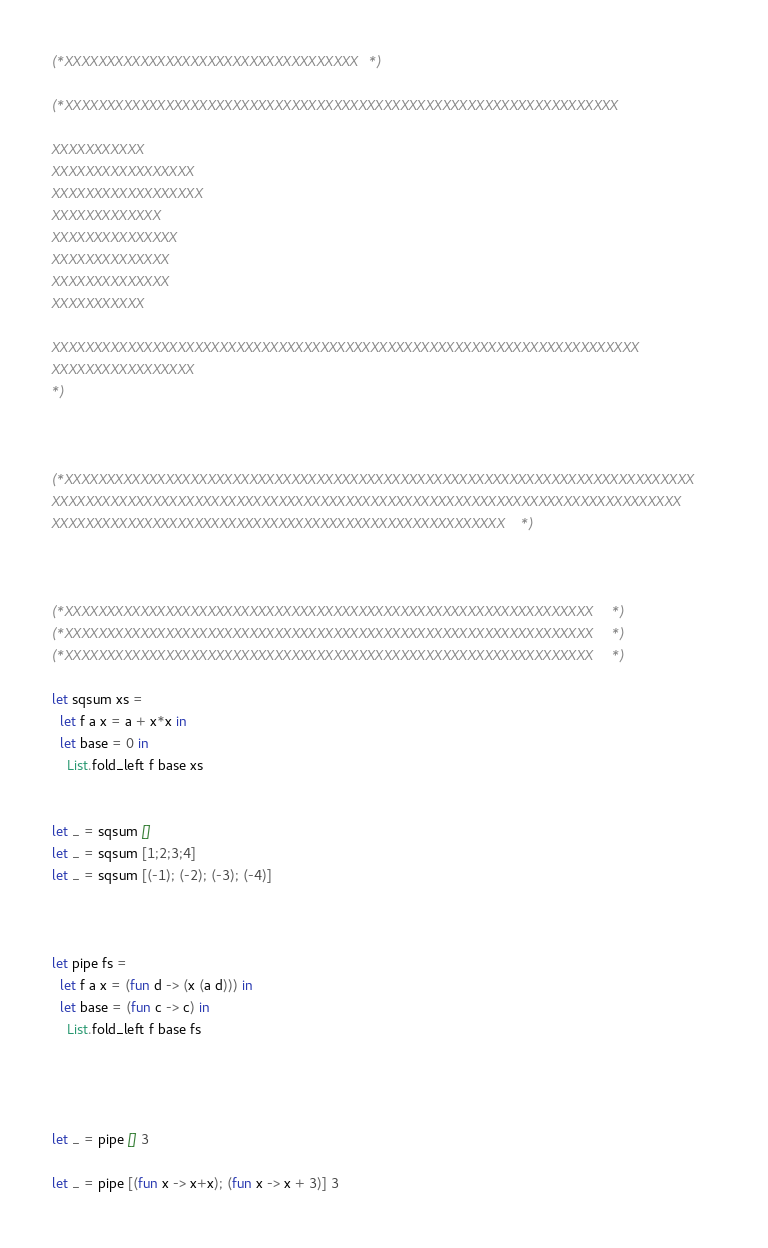Convert code to text. <code><loc_0><loc_0><loc_500><loc_500><_OCaml_>(*XXXXXXXXXXXXXXXXXXXXXXXXXXXXXXXXXXX*)

(*XXXXXXXXXXXXXXXXXXXXXXXXXXXXXXXXXXXXXXXXXXXXXXXXXXXXXXXXXXXXXXXXXX

XXXXXXXXXXX
XXXXXXXXXXXXXXXXX
XXXXXXXXXXXXXXXXXX
XXXXXXXXXXXXX
XXXXXXXXXXXXXXX
XXXXXXXXXXXXXX
XXXXXXXXXXXXXX
XXXXXXXXXXX

XXXXXXXXXXXXXXXXXXXXXXXXXXXXXXXXXXXXXXXXXXXXXXXXXXXXXXXXXXXXXXXXXXXXXX
XXXXXXXXXXXXXXXXX
*)



(*XXXXXXXXXXXXXXXXXXXXXXXXXXXXXXXXXXXXXXXXXXXXXXXXXXXXXXXXXXXXXXXXXXXXXXXXXXX
XXXXXXXXXXXXXXXXXXXXXXXXXXXXXXXXXXXXXXXXXXXXXXXXXXXXXXXXXXXXXXXXXXXXXXXXXXX
XXXXXXXXXXXXXXXXXXXXXXXXXXXXXXXXXXXXXXXXXXXXXXXXXXXXXX*)



(*XXXXXXXXXXXXXXXXXXXXXXXXXXXXXXXXXXXXXXXXXXXXXXXXXXXXXXXXXXXXXXX*)
(*XXXXXXXXXXXXXXXXXXXXXXXXXXXXXXXXXXXXXXXXXXXXXXXXXXXXXXXXXXXXXXX*)
(*XXXXXXXXXXXXXXXXXXXXXXXXXXXXXXXXXXXXXXXXXXXXXXXXXXXXXXXXXXXXXXX*)

let sqsum xs = 
  let f a x = a + x*x in
  let base = 0 in
    List.fold_left f base xs


let _ = sqsum []
let _ = sqsum [1;2;3;4]
let _ = sqsum [(-1); (-2); (-3); (-4)]



let pipe fs = 
  let f a x = (fun d -> (x (a d))) in
  let base = (fun c -> c) in
    List.fold_left f base fs




let _ = pipe [] 3

let _ = pipe [(fun x -> x+x); (fun x -> x + 3)] 3
</code> 